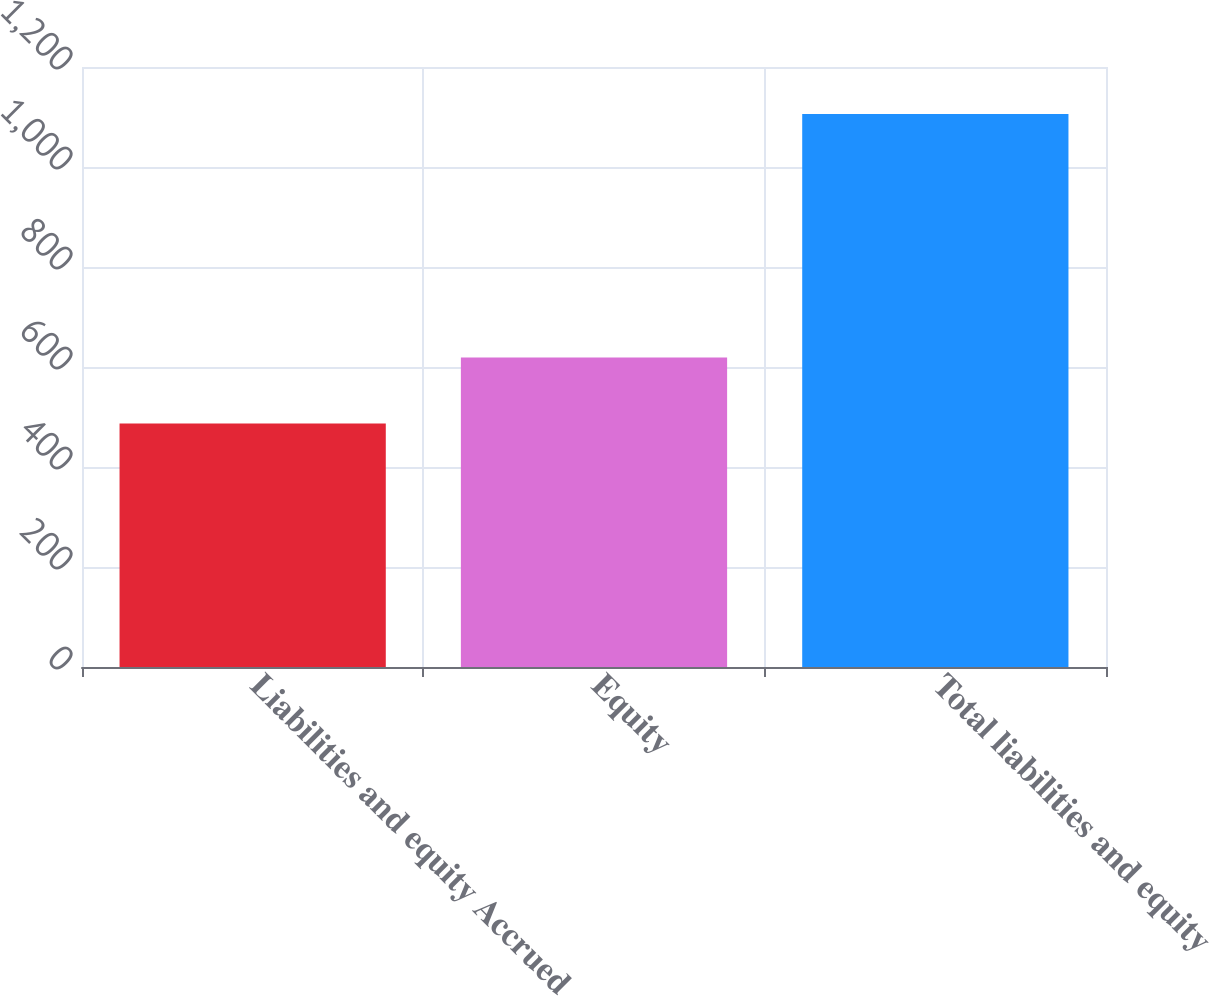Convert chart to OTSL. <chart><loc_0><loc_0><loc_500><loc_500><bar_chart><fcel>Liabilities and equity Accrued<fcel>Equity<fcel>Total liabilities and equity<nl><fcel>487<fcel>619<fcel>1106<nl></chart> 